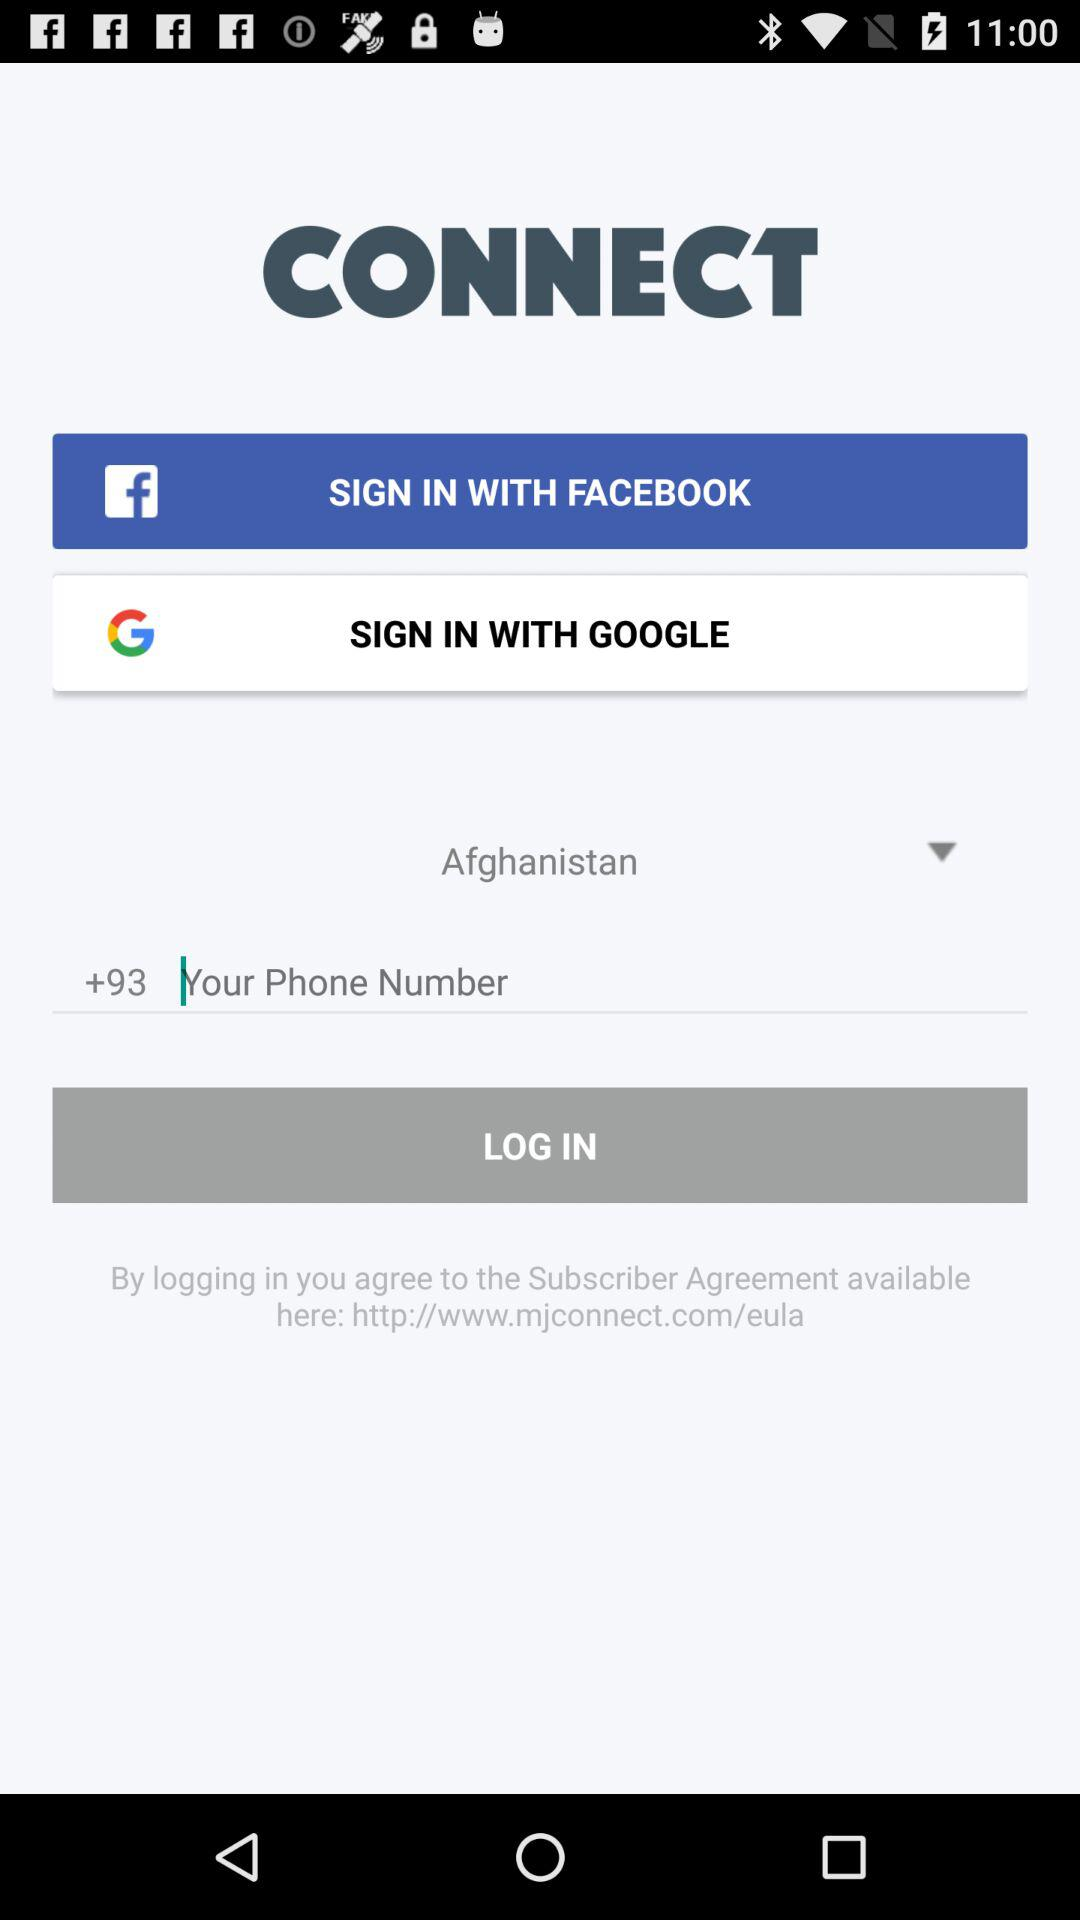Which country is selected? The selected country is Afghanistan. 